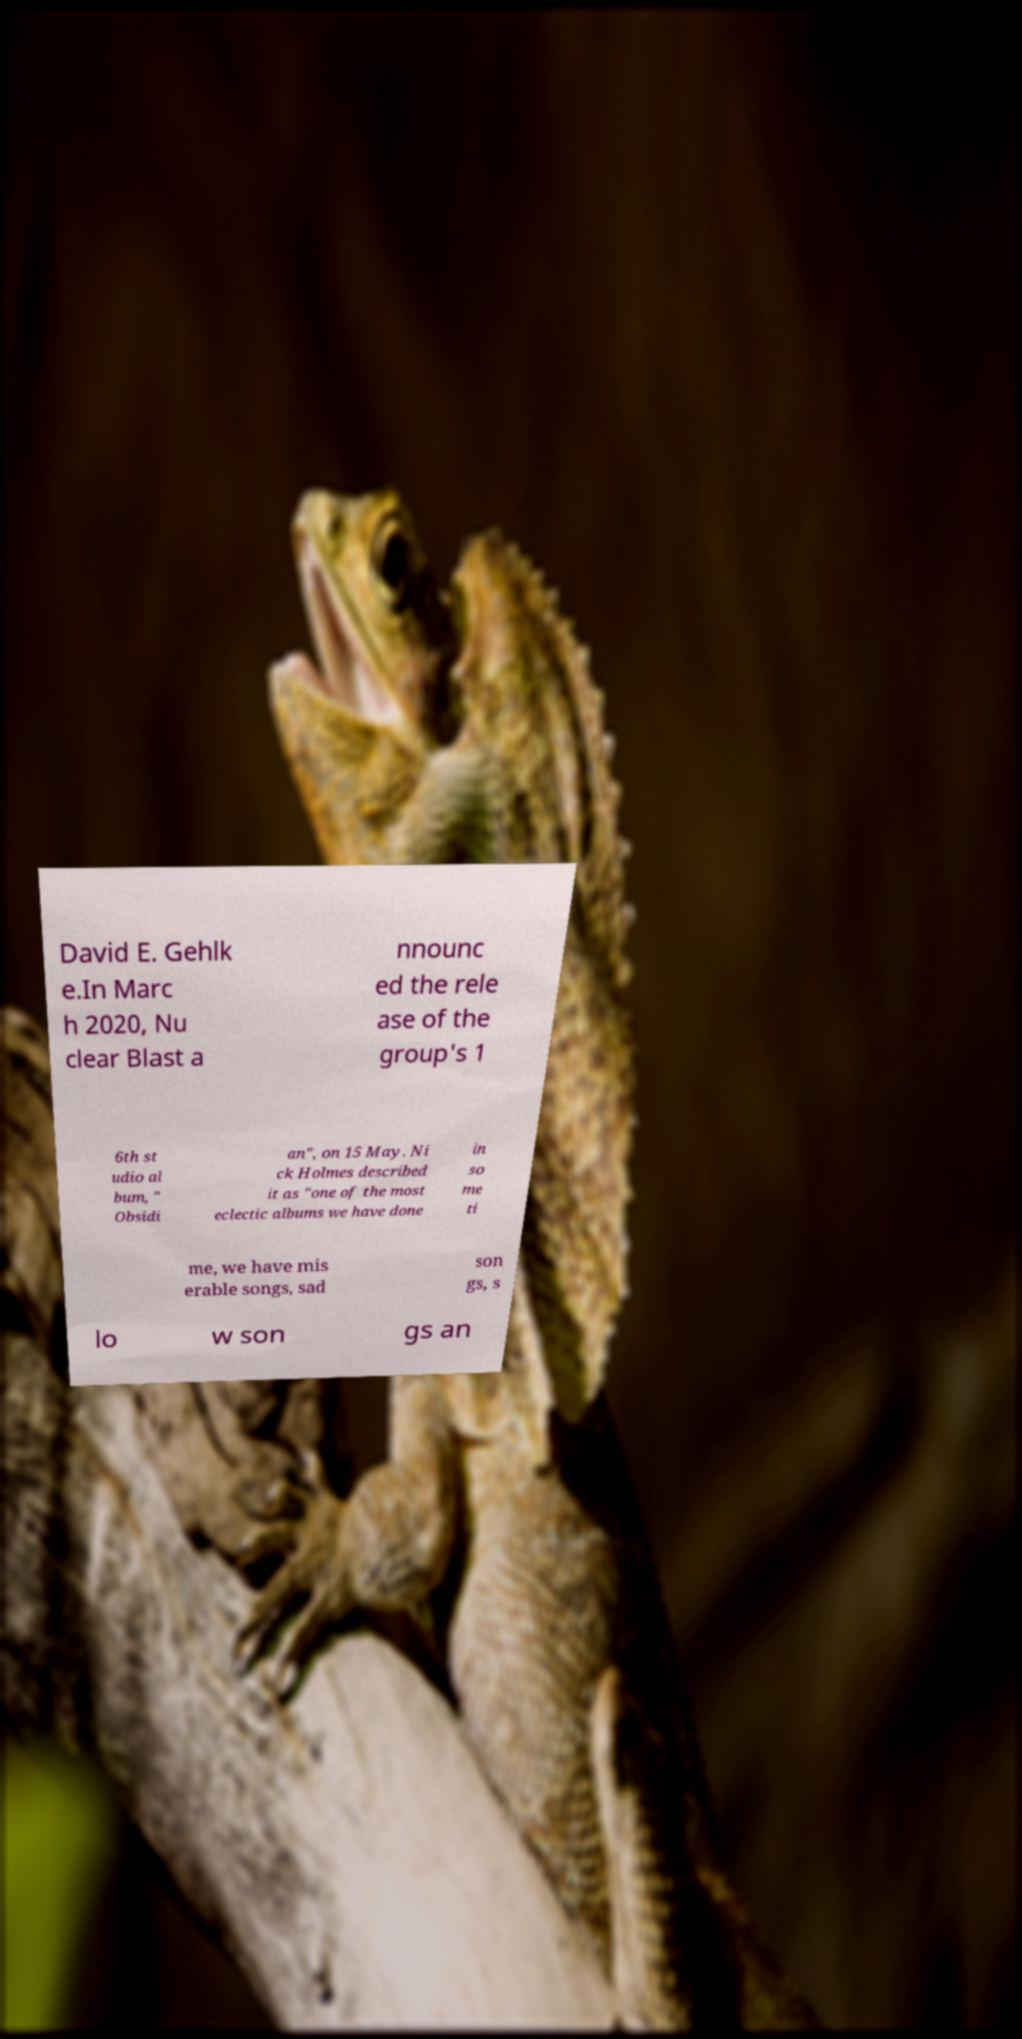Please read and relay the text visible in this image. What does it say? David E. Gehlk e.In Marc h 2020, Nu clear Blast a nnounc ed the rele ase of the group's 1 6th st udio al bum, " Obsidi an", on 15 May. Ni ck Holmes described it as "one of the most eclectic albums we have done in so me ti me, we have mis erable songs, sad son gs, s lo w son gs an 